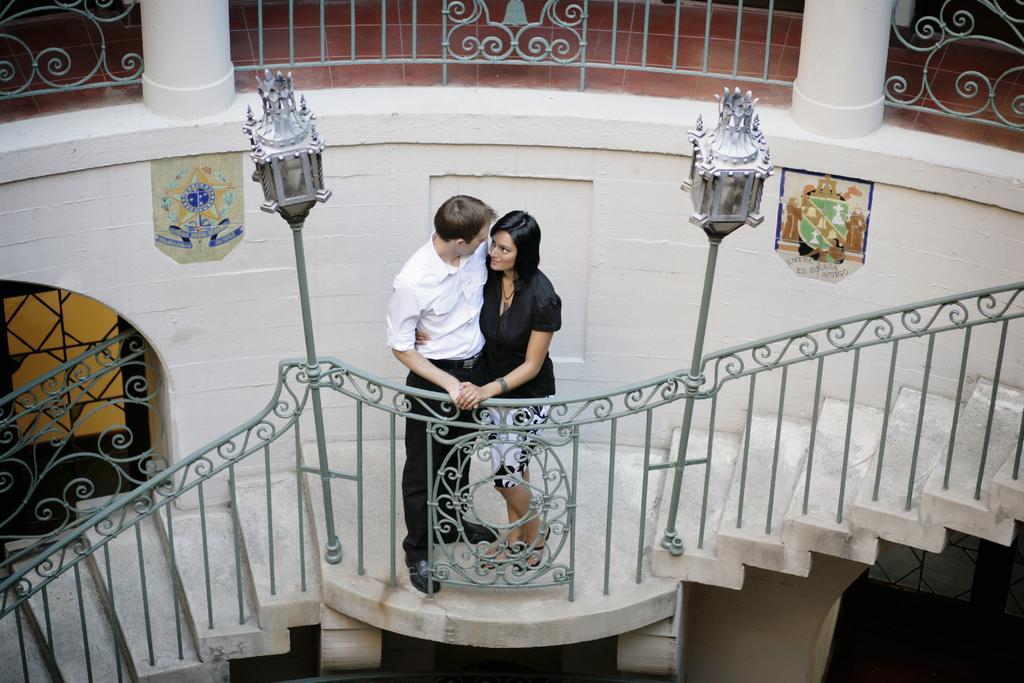Could you give a brief overview of what you see in this image? In this image we can see a man and woman are standing on the stairs. In front of them railing and two poles are there. The man is wearing a white shirt and pant, the woman is wearing black dress. Behind them white color wall, grey railing and two pillars are there. 